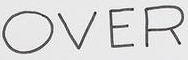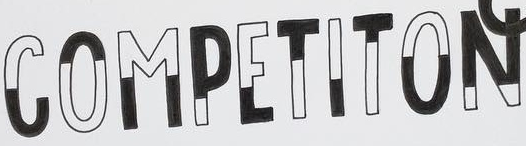What text appears in these images from left to right, separated by a semicolon? OVER; COMPETITON 